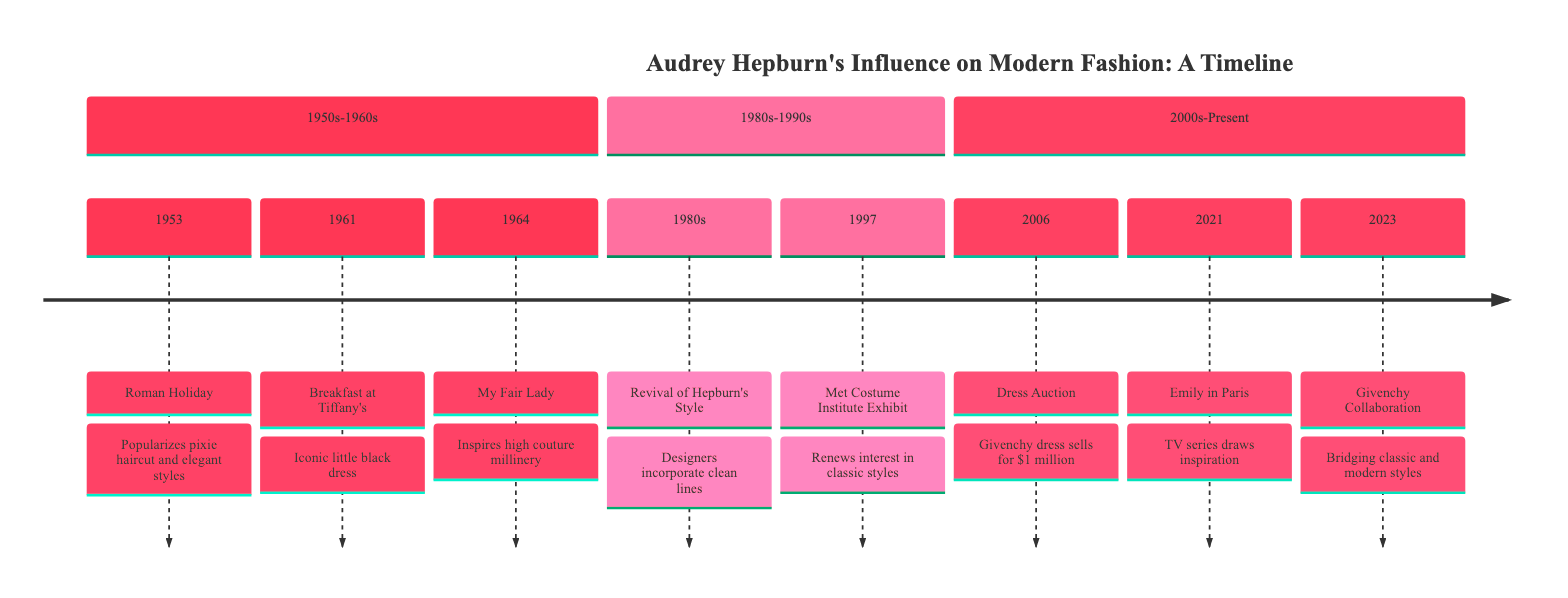What event popularized the pixie haircut? In 1953, "Roman Holiday" starring Audrey Hepburn led to the popularization of the pixie haircut, which is explicitly mentioned in the event's description.
Answer: Roman Holiday What year did 'Breakfast at Tiffany's' release? The timeline marks the year 1961 with the event 'Breakfast at Tiffany’s', indicating it is the year of the release.
Answer: 1961 Which designer created the iconic little black dress worn by Hepburn in 'Breakfast at Tiffany's'? The timeline notes that the little black dress worn by Hepburn was designed by Givenchy, as mentioned in the impact of the 1961 event.
Answer: Givenchy How much did Hepburn's Givenchy dress sell for at auction in 2006? The timeline states that Hepburn’s Givenchy dress from 'Breakfast at Tiffany’s' sold for nearly $1 million, which is a clear figure given in the 2006 event.
Answer: nearly $1 million What common theme is observed in the 1980s regarding Hepburn's influence? The event in the 1980s discusses a revival of Hepburn's style, highlighting that designers incorporated clean lines and minimalist designs from her era into their work.
Answer: Revival of Hepburn's Style In what year was the fashion retrospective at the Metropolitan Museum of Art held? The timeline states that the fashion retrospective took place in 1997, explicitly identified in the event's description.
Answer: 1997 Which series drew inspiration from Audrey Hepburn's style in 2021? The timeline cites that the Netflix series "Emily in Paris" featured outfits inspired by Audrey Hepburn, making it the focus of the 2021 event.
Answer: Emily in Paris What significant impact did Hepburn's 1964 style have on fashion? The description of Hepburn's style in 'My Fair Lady' in 1964 highlights that it inspired high couture millinery and opulently adorned gowns, capturing the impact of that event.
Answer: Inspires high couture millinery What is the year associated with the collaboration between Givenchy and emerging designers? The timeline specifies that the collaboration occurred in 2023, as stated in the last event's information.
Answer: 2023 